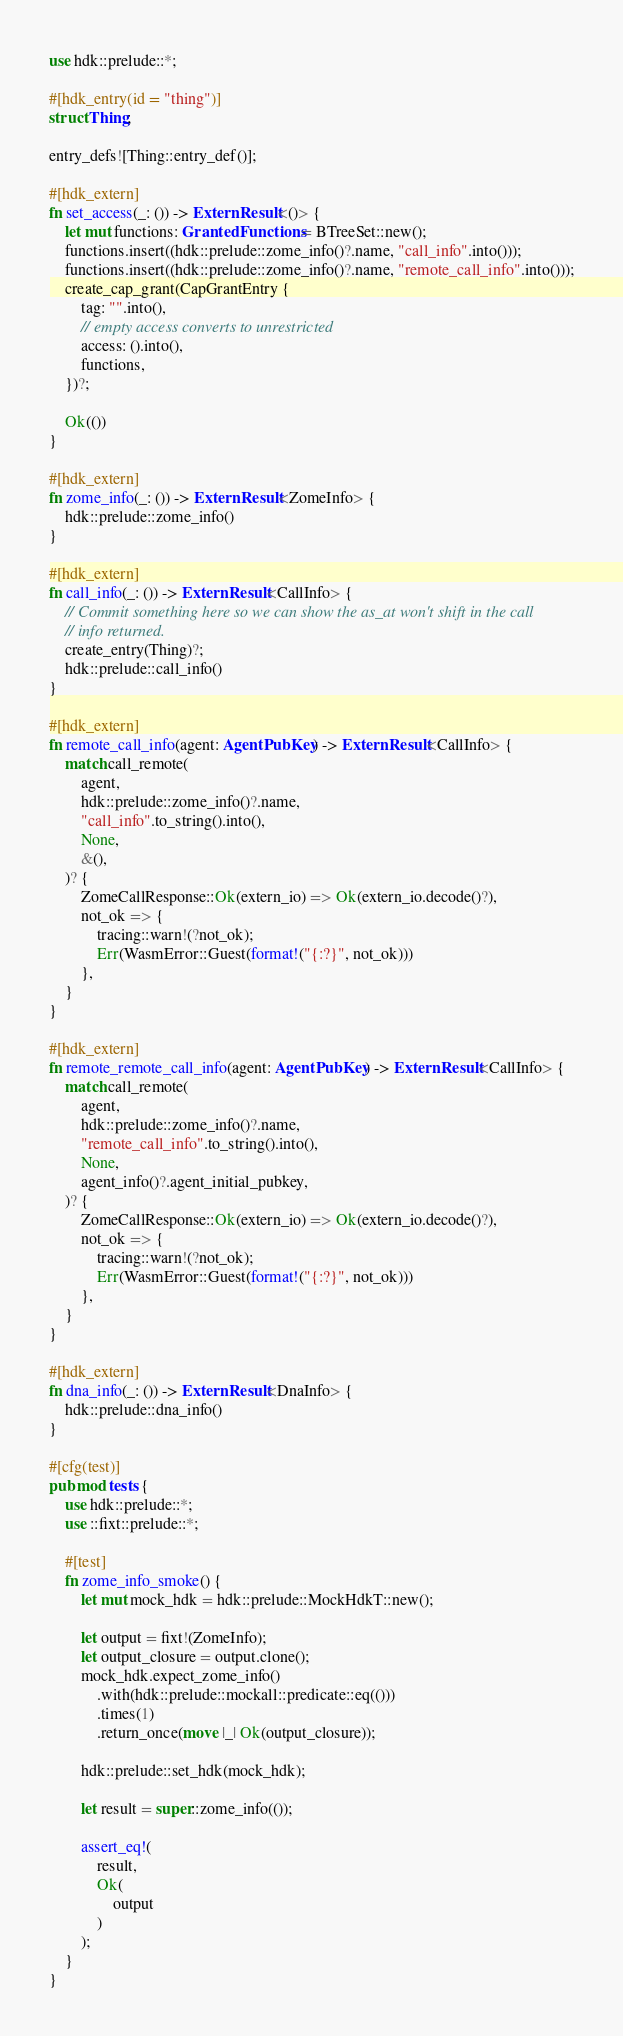Convert code to text. <code><loc_0><loc_0><loc_500><loc_500><_Rust_>use hdk::prelude::*;

#[hdk_entry(id = "thing")]
struct Thing;

entry_defs![Thing::entry_def()];

#[hdk_extern]
fn set_access(_: ()) -> ExternResult<()> {
    let mut functions: GrantedFunctions = BTreeSet::new();
    functions.insert((hdk::prelude::zome_info()?.name, "call_info".into()));
    functions.insert((hdk::prelude::zome_info()?.name, "remote_call_info".into()));
    create_cap_grant(CapGrantEntry {
        tag: "".into(),
        // empty access converts to unrestricted
        access: ().into(),
        functions,
    })?;

    Ok(())
}

#[hdk_extern]
fn zome_info(_: ()) -> ExternResult<ZomeInfo> {
    hdk::prelude::zome_info()
}

#[hdk_extern]
fn call_info(_: ()) -> ExternResult<CallInfo> {
    // Commit something here so we can show the as_at won't shift in the call
    // info returned.
    create_entry(Thing)?;
    hdk::prelude::call_info()
}

#[hdk_extern]
fn remote_call_info(agent: AgentPubKey) -> ExternResult<CallInfo> {
    match call_remote(
        agent,
        hdk::prelude::zome_info()?.name,
        "call_info".to_string().into(),
        None,
        &(),
    )? {
        ZomeCallResponse::Ok(extern_io) => Ok(extern_io.decode()?),
        not_ok => {
            tracing::warn!(?not_ok);
            Err(WasmError::Guest(format!("{:?}", not_ok)))
        },
    }
}

#[hdk_extern]
fn remote_remote_call_info(agent: AgentPubKey) -> ExternResult<CallInfo> {
    match call_remote(
        agent,
        hdk::prelude::zome_info()?.name,
        "remote_call_info".to_string().into(),
        None,
        agent_info()?.agent_initial_pubkey,
    )? {
        ZomeCallResponse::Ok(extern_io) => Ok(extern_io.decode()?),
        not_ok => {
            tracing::warn!(?not_ok);
            Err(WasmError::Guest(format!("{:?}", not_ok)))
        },
    }
}

#[hdk_extern]
fn dna_info(_: ()) -> ExternResult<DnaInfo> {
    hdk::prelude::dna_info()
}

#[cfg(test)]
pub mod tests {
    use hdk::prelude::*;
    use ::fixt::prelude::*;

    #[test]
    fn zome_info_smoke() {
        let mut mock_hdk = hdk::prelude::MockHdkT::new();

        let output = fixt!(ZomeInfo);
        let output_closure = output.clone();
        mock_hdk.expect_zome_info()
            .with(hdk::prelude::mockall::predicate::eq(()))
            .times(1)
            .return_once(move |_| Ok(output_closure));

        hdk::prelude::set_hdk(mock_hdk);

        let result = super::zome_info(());

        assert_eq!(
            result,
            Ok(
                output
            )
        );
    }
}</code> 